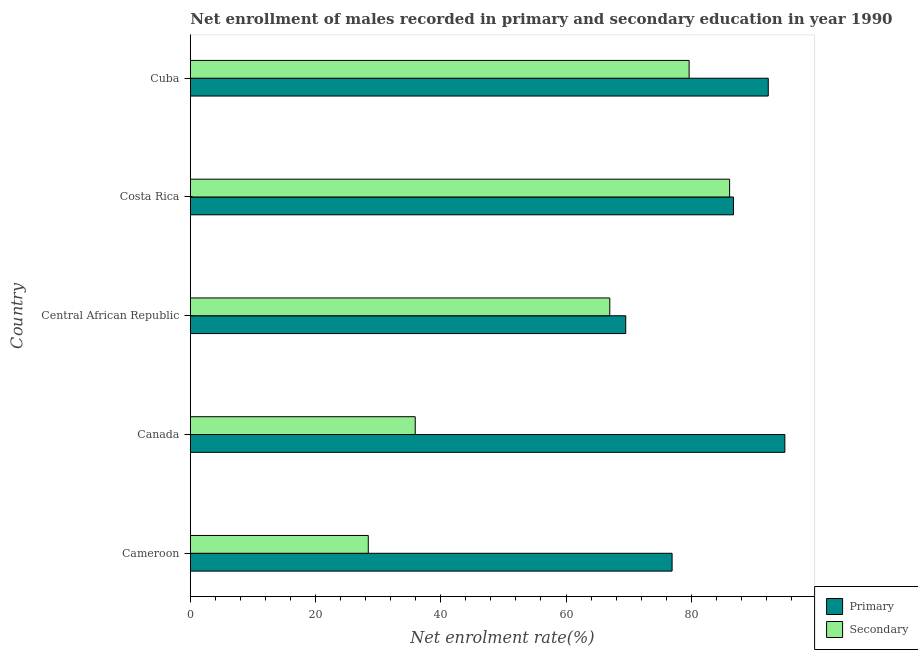How many different coloured bars are there?
Provide a short and direct response. 2. How many bars are there on the 4th tick from the top?
Your answer should be compact. 2. How many bars are there on the 3rd tick from the bottom?
Your answer should be compact. 2. What is the label of the 1st group of bars from the top?
Your response must be concise. Cuba. What is the enrollment rate in secondary education in Central African Republic?
Offer a very short reply. 66.99. Across all countries, what is the maximum enrollment rate in primary education?
Provide a succinct answer. 94.95. Across all countries, what is the minimum enrollment rate in secondary education?
Provide a succinct answer. 28.42. In which country was the enrollment rate in secondary education minimum?
Provide a short and direct response. Cameroon. What is the total enrollment rate in secondary education in the graph?
Give a very brief answer. 297.12. What is the difference between the enrollment rate in primary education in Central African Republic and that in Cuba?
Make the answer very short. -22.76. What is the difference between the enrollment rate in secondary education in Cameroon and the enrollment rate in primary education in Canada?
Ensure brevity in your answer.  -66.52. What is the average enrollment rate in primary education per country?
Your answer should be compact. 84.09. What is the difference between the enrollment rate in primary education and enrollment rate in secondary education in Cuba?
Offer a very short reply. 12.64. What is the ratio of the enrollment rate in primary education in Canada to that in Costa Rica?
Offer a terse response. 1.09. Is the enrollment rate in primary education in Canada less than that in Costa Rica?
Provide a short and direct response. No. Is the difference between the enrollment rate in secondary education in Cameroon and Central African Republic greater than the difference between the enrollment rate in primary education in Cameroon and Central African Republic?
Make the answer very short. No. What is the difference between the highest and the second highest enrollment rate in primary education?
Provide a succinct answer. 2.65. What is the difference between the highest and the lowest enrollment rate in primary education?
Ensure brevity in your answer.  25.41. What does the 2nd bar from the top in Canada represents?
Offer a very short reply. Primary. What does the 1st bar from the bottom in Central African Republic represents?
Offer a very short reply. Primary. How many bars are there?
Your response must be concise. 10. Are all the bars in the graph horizontal?
Keep it short and to the point. Yes. How many countries are there in the graph?
Make the answer very short. 5. Does the graph contain any zero values?
Your answer should be very brief. No. Does the graph contain grids?
Offer a very short reply. No. Where does the legend appear in the graph?
Give a very brief answer. Bottom right. What is the title of the graph?
Offer a terse response. Net enrollment of males recorded in primary and secondary education in year 1990. Does "Nonresident" appear as one of the legend labels in the graph?
Your answer should be compact. No. What is the label or title of the X-axis?
Give a very brief answer. Net enrolment rate(%). What is the Net enrolment rate(%) of Primary in Cameroon?
Provide a short and direct response. 76.94. What is the Net enrolment rate(%) in Secondary in Cameroon?
Make the answer very short. 28.42. What is the Net enrolment rate(%) in Primary in Canada?
Your answer should be compact. 94.95. What is the Net enrolment rate(%) in Secondary in Canada?
Provide a short and direct response. 35.92. What is the Net enrolment rate(%) in Primary in Central African Republic?
Provide a short and direct response. 69.54. What is the Net enrolment rate(%) of Secondary in Central African Republic?
Give a very brief answer. 66.99. What is the Net enrolment rate(%) in Primary in Costa Rica?
Offer a terse response. 86.74. What is the Net enrolment rate(%) of Secondary in Costa Rica?
Provide a short and direct response. 86.13. What is the Net enrolment rate(%) of Primary in Cuba?
Provide a short and direct response. 92.3. What is the Net enrolment rate(%) in Secondary in Cuba?
Provide a short and direct response. 79.66. Across all countries, what is the maximum Net enrolment rate(%) in Primary?
Offer a very short reply. 94.95. Across all countries, what is the maximum Net enrolment rate(%) of Secondary?
Offer a very short reply. 86.13. Across all countries, what is the minimum Net enrolment rate(%) of Primary?
Provide a succinct answer. 69.54. Across all countries, what is the minimum Net enrolment rate(%) of Secondary?
Your answer should be compact. 28.42. What is the total Net enrolment rate(%) in Primary in the graph?
Ensure brevity in your answer.  420.46. What is the total Net enrolment rate(%) of Secondary in the graph?
Offer a very short reply. 297.12. What is the difference between the Net enrolment rate(%) in Primary in Cameroon and that in Canada?
Make the answer very short. -18.01. What is the difference between the Net enrolment rate(%) in Secondary in Cameroon and that in Canada?
Offer a terse response. -7.5. What is the difference between the Net enrolment rate(%) of Primary in Cameroon and that in Central African Republic?
Make the answer very short. 7.4. What is the difference between the Net enrolment rate(%) in Secondary in Cameroon and that in Central African Republic?
Your response must be concise. -38.57. What is the difference between the Net enrolment rate(%) of Primary in Cameroon and that in Costa Rica?
Your answer should be compact. -9.8. What is the difference between the Net enrolment rate(%) in Secondary in Cameroon and that in Costa Rica?
Keep it short and to the point. -57.7. What is the difference between the Net enrolment rate(%) in Primary in Cameroon and that in Cuba?
Offer a terse response. -15.36. What is the difference between the Net enrolment rate(%) in Secondary in Cameroon and that in Cuba?
Provide a short and direct response. -51.24. What is the difference between the Net enrolment rate(%) of Primary in Canada and that in Central African Republic?
Make the answer very short. 25.41. What is the difference between the Net enrolment rate(%) of Secondary in Canada and that in Central African Republic?
Give a very brief answer. -31.07. What is the difference between the Net enrolment rate(%) of Primary in Canada and that in Costa Rica?
Provide a short and direct response. 8.21. What is the difference between the Net enrolment rate(%) of Secondary in Canada and that in Costa Rica?
Your answer should be very brief. -50.21. What is the difference between the Net enrolment rate(%) of Primary in Canada and that in Cuba?
Provide a succinct answer. 2.65. What is the difference between the Net enrolment rate(%) in Secondary in Canada and that in Cuba?
Give a very brief answer. -43.74. What is the difference between the Net enrolment rate(%) of Primary in Central African Republic and that in Costa Rica?
Make the answer very short. -17.2. What is the difference between the Net enrolment rate(%) of Secondary in Central African Republic and that in Costa Rica?
Provide a short and direct response. -19.14. What is the difference between the Net enrolment rate(%) in Primary in Central African Republic and that in Cuba?
Your response must be concise. -22.76. What is the difference between the Net enrolment rate(%) of Secondary in Central African Republic and that in Cuba?
Ensure brevity in your answer.  -12.67. What is the difference between the Net enrolment rate(%) in Primary in Costa Rica and that in Cuba?
Provide a succinct answer. -5.56. What is the difference between the Net enrolment rate(%) in Secondary in Costa Rica and that in Cuba?
Make the answer very short. 6.47. What is the difference between the Net enrolment rate(%) of Primary in Cameroon and the Net enrolment rate(%) of Secondary in Canada?
Make the answer very short. 41.02. What is the difference between the Net enrolment rate(%) in Primary in Cameroon and the Net enrolment rate(%) in Secondary in Central African Republic?
Give a very brief answer. 9.95. What is the difference between the Net enrolment rate(%) in Primary in Cameroon and the Net enrolment rate(%) in Secondary in Costa Rica?
Offer a very short reply. -9.19. What is the difference between the Net enrolment rate(%) of Primary in Cameroon and the Net enrolment rate(%) of Secondary in Cuba?
Ensure brevity in your answer.  -2.72. What is the difference between the Net enrolment rate(%) of Primary in Canada and the Net enrolment rate(%) of Secondary in Central African Republic?
Offer a terse response. 27.96. What is the difference between the Net enrolment rate(%) of Primary in Canada and the Net enrolment rate(%) of Secondary in Costa Rica?
Make the answer very short. 8.82. What is the difference between the Net enrolment rate(%) in Primary in Canada and the Net enrolment rate(%) in Secondary in Cuba?
Offer a very short reply. 15.29. What is the difference between the Net enrolment rate(%) of Primary in Central African Republic and the Net enrolment rate(%) of Secondary in Costa Rica?
Your response must be concise. -16.59. What is the difference between the Net enrolment rate(%) of Primary in Central African Republic and the Net enrolment rate(%) of Secondary in Cuba?
Your answer should be very brief. -10.12. What is the difference between the Net enrolment rate(%) of Primary in Costa Rica and the Net enrolment rate(%) of Secondary in Cuba?
Provide a succinct answer. 7.08. What is the average Net enrolment rate(%) in Primary per country?
Make the answer very short. 84.09. What is the average Net enrolment rate(%) of Secondary per country?
Make the answer very short. 59.42. What is the difference between the Net enrolment rate(%) of Primary and Net enrolment rate(%) of Secondary in Cameroon?
Your answer should be very brief. 48.52. What is the difference between the Net enrolment rate(%) in Primary and Net enrolment rate(%) in Secondary in Canada?
Your answer should be very brief. 59.03. What is the difference between the Net enrolment rate(%) in Primary and Net enrolment rate(%) in Secondary in Central African Republic?
Make the answer very short. 2.55. What is the difference between the Net enrolment rate(%) of Primary and Net enrolment rate(%) of Secondary in Costa Rica?
Make the answer very short. 0.61. What is the difference between the Net enrolment rate(%) of Primary and Net enrolment rate(%) of Secondary in Cuba?
Give a very brief answer. 12.64. What is the ratio of the Net enrolment rate(%) in Primary in Cameroon to that in Canada?
Provide a short and direct response. 0.81. What is the ratio of the Net enrolment rate(%) in Secondary in Cameroon to that in Canada?
Keep it short and to the point. 0.79. What is the ratio of the Net enrolment rate(%) of Primary in Cameroon to that in Central African Republic?
Give a very brief answer. 1.11. What is the ratio of the Net enrolment rate(%) of Secondary in Cameroon to that in Central African Republic?
Your answer should be compact. 0.42. What is the ratio of the Net enrolment rate(%) of Primary in Cameroon to that in Costa Rica?
Make the answer very short. 0.89. What is the ratio of the Net enrolment rate(%) of Secondary in Cameroon to that in Costa Rica?
Your response must be concise. 0.33. What is the ratio of the Net enrolment rate(%) of Primary in Cameroon to that in Cuba?
Your answer should be compact. 0.83. What is the ratio of the Net enrolment rate(%) of Secondary in Cameroon to that in Cuba?
Provide a succinct answer. 0.36. What is the ratio of the Net enrolment rate(%) of Primary in Canada to that in Central African Republic?
Provide a succinct answer. 1.37. What is the ratio of the Net enrolment rate(%) in Secondary in Canada to that in Central African Republic?
Give a very brief answer. 0.54. What is the ratio of the Net enrolment rate(%) in Primary in Canada to that in Costa Rica?
Provide a succinct answer. 1.09. What is the ratio of the Net enrolment rate(%) of Secondary in Canada to that in Costa Rica?
Offer a very short reply. 0.42. What is the ratio of the Net enrolment rate(%) of Primary in Canada to that in Cuba?
Give a very brief answer. 1.03. What is the ratio of the Net enrolment rate(%) of Secondary in Canada to that in Cuba?
Keep it short and to the point. 0.45. What is the ratio of the Net enrolment rate(%) of Primary in Central African Republic to that in Costa Rica?
Make the answer very short. 0.8. What is the ratio of the Net enrolment rate(%) in Secondary in Central African Republic to that in Costa Rica?
Provide a succinct answer. 0.78. What is the ratio of the Net enrolment rate(%) in Primary in Central African Republic to that in Cuba?
Offer a very short reply. 0.75. What is the ratio of the Net enrolment rate(%) in Secondary in Central African Republic to that in Cuba?
Keep it short and to the point. 0.84. What is the ratio of the Net enrolment rate(%) of Primary in Costa Rica to that in Cuba?
Make the answer very short. 0.94. What is the ratio of the Net enrolment rate(%) in Secondary in Costa Rica to that in Cuba?
Offer a terse response. 1.08. What is the difference between the highest and the second highest Net enrolment rate(%) of Primary?
Provide a succinct answer. 2.65. What is the difference between the highest and the second highest Net enrolment rate(%) in Secondary?
Your answer should be compact. 6.47. What is the difference between the highest and the lowest Net enrolment rate(%) of Primary?
Your response must be concise. 25.41. What is the difference between the highest and the lowest Net enrolment rate(%) in Secondary?
Provide a succinct answer. 57.7. 